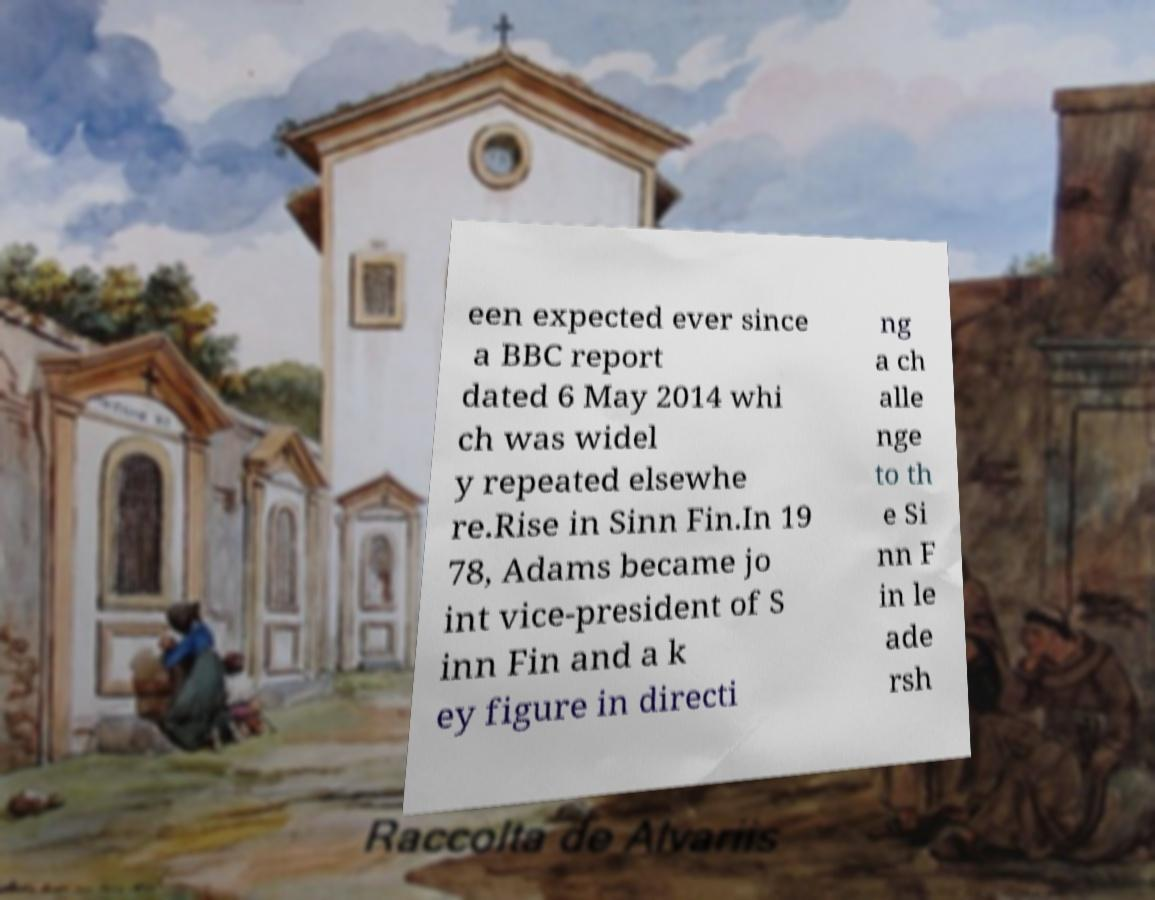Can you read and provide the text displayed in the image?This photo seems to have some interesting text. Can you extract and type it out for me? een expected ever since a BBC report dated 6 May 2014 whi ch was widel y repeated elsewhe re.Rise in Sinn Fin.In 19 78, Adams became jo int vice-president of S inn Fin and a k ey figure in directi ng a ch alle nge to th e Si nn F in le ade rsh 